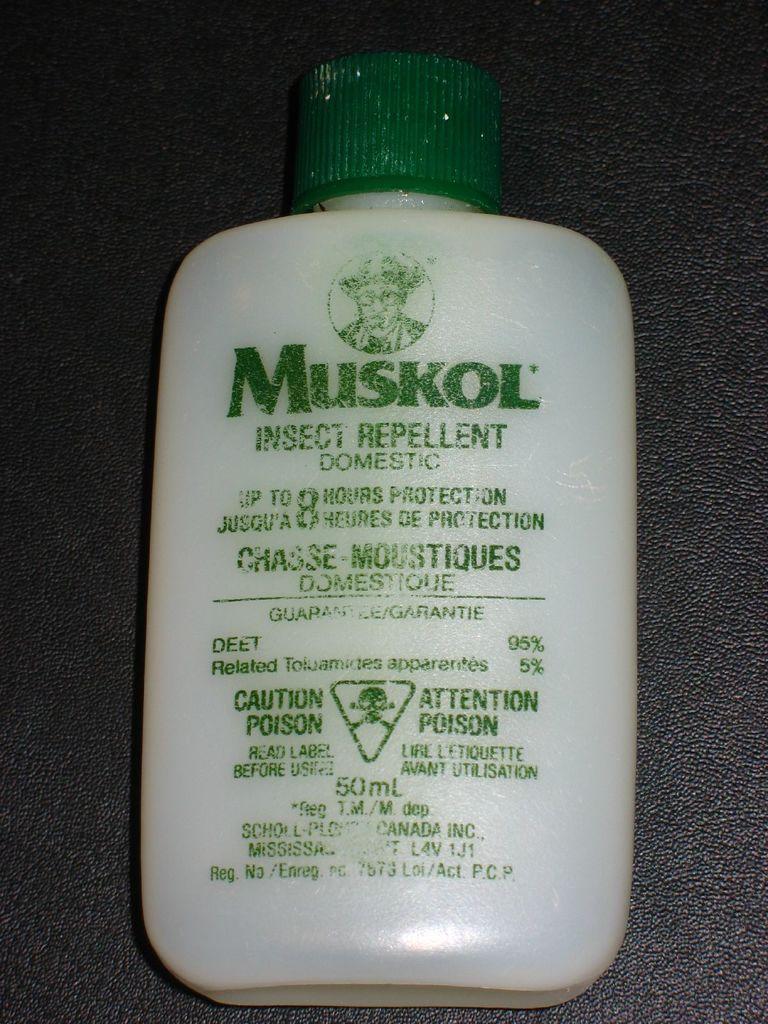Describe this image in one or two sentences. In this image I can see a plastic bottle with the name of Muskol on it. 